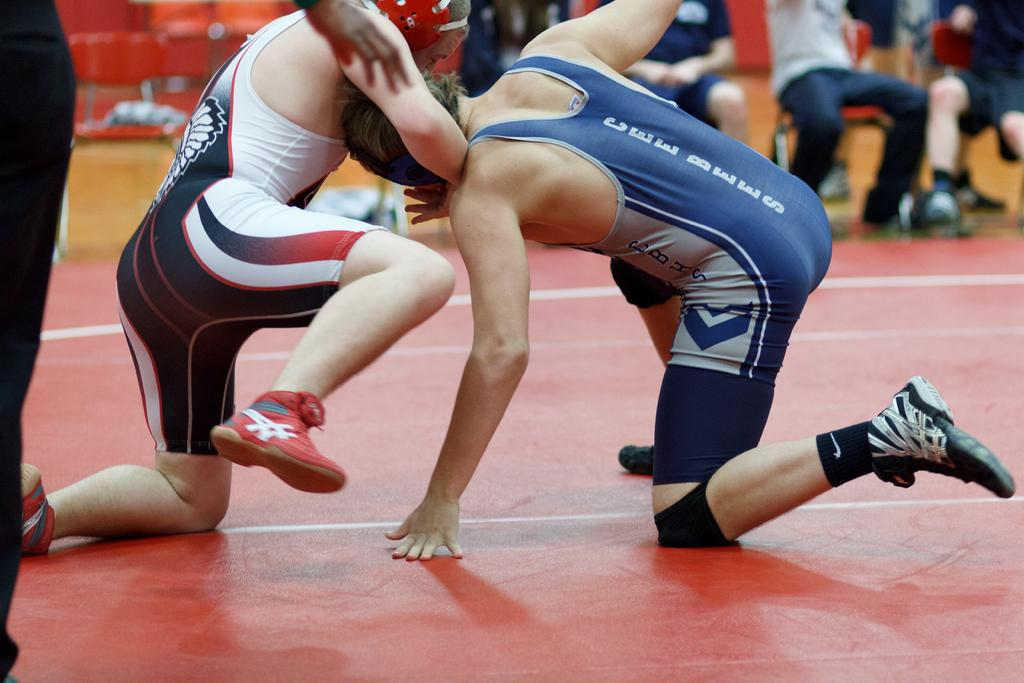<image>
Describe the image concisely. A wrestler wearing a Cee Bees uniform is competing against a wrestler wearing red, white and blue. 